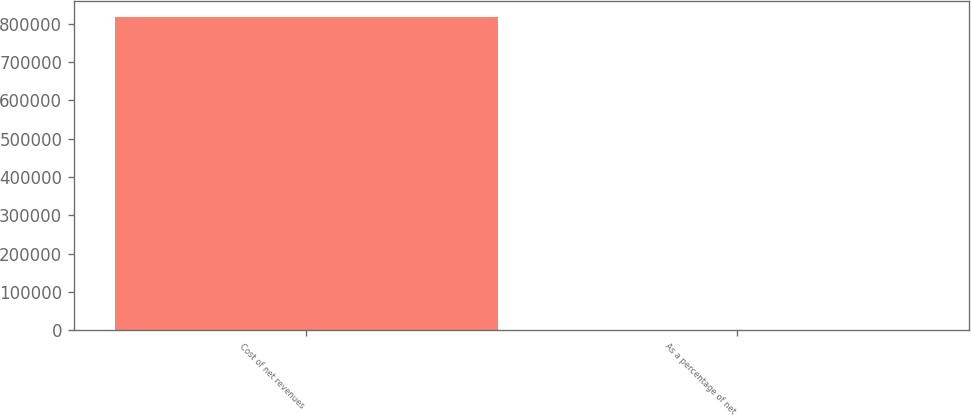Convert chart. <chart><loc_0><loc_0><loc_500><loc_500><bar_chart><fcel>Cost of net revenues<fcel>As a percentage of net<nl><fcel>818104<fcel>18<nl></chart> 